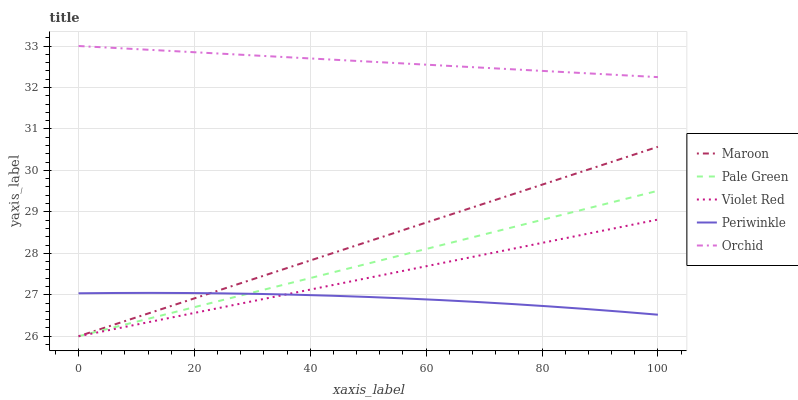Does Periwinkle have the minimum area under the curve?
Answer yes or no. Yes. Does Orchid have the maximum area under the curve?
Answer yes or no. Yes. Does Pale Green have the minimum area under the curve?
Answer yes or no. No. Does Pale Green have the maximum area under the curve?
Answer yes or no. No. Is Pale Green the smoothest?
Answer yes or no. Yes. Is Periwinkle the roughest?
Answer yes or no. Yes. Is Periwinkle the smoothest?
Answer yes or no. No. Is Pale Green the roughest?
Answer yes or no. No. Does Violet Red have the lowest value?
Answer yes or no. Yes. Does Periwinkle have the lowest value?
Answer yes or no. No. Does Orchid have the highest value?
Answer yes or no. Yes. Does Pale Green have the highest value?
Answer yes or no. No. Is Pale Green less than Orchid?
Answer yes or no. Yes. Is Orchid greater than Violet Red?
Answer yes or no. Yes. Does Maroon intersect Pale Green?
Answer yes or no. Yes. Is Maroon less than Pale Green?
Answer yes or no. No. Is Maroon greater than Pale Green?
Answer yes or no. No. Does Pale Green intersect Orchid?
Answer yes or no. No. 